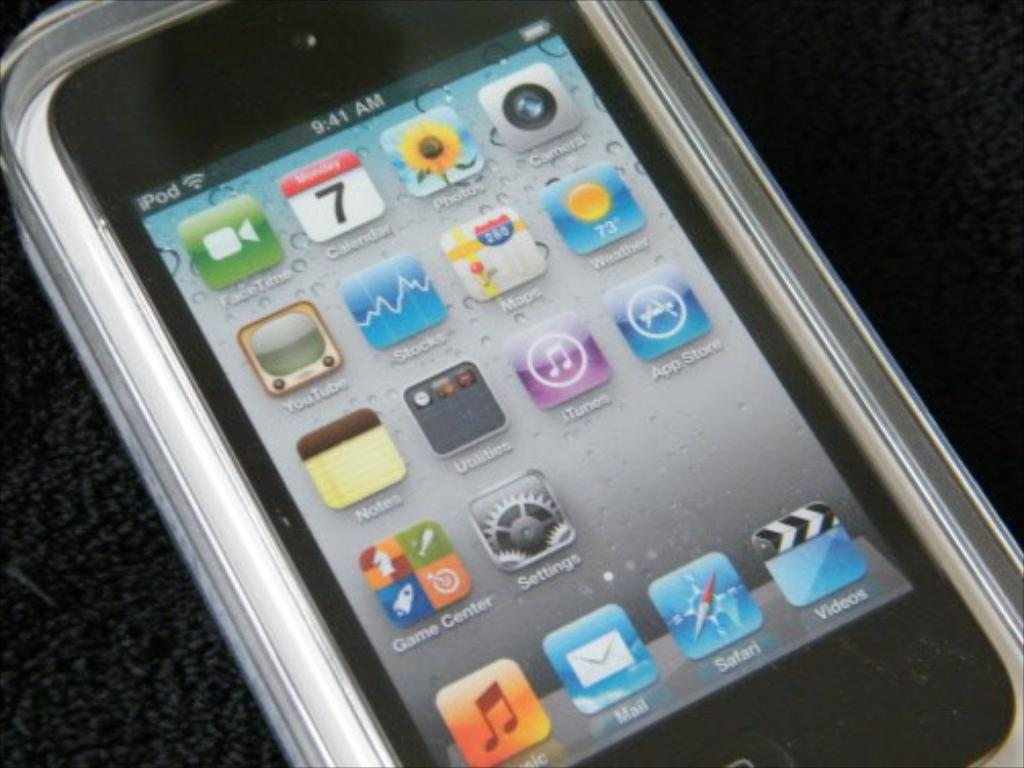<image>
Create a compact narrative representing the image presented. the word mail is on the envelope on the screen 